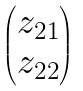Convert formula to latex. <formula><loc_0><loc_0><loc_500><loc_500>\begin{pmatrix} z _ { 2 1 } \\ z _ { 2 2 } \end{pmatrix}</formula> 